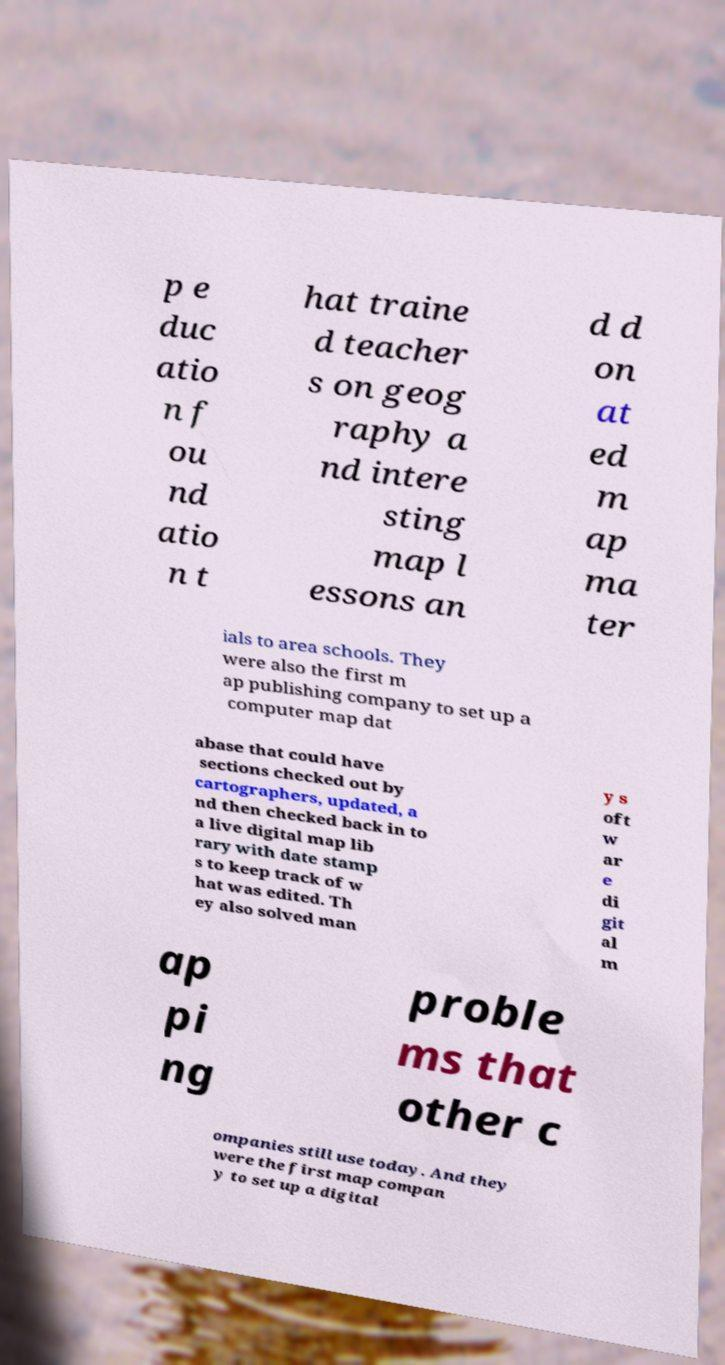Could you extract and type out the text from this image? p e duc atio n f ou nd atio n t hat traine d teacher s on geog raphy a nd intere sting map l essons an d d on at ed m ap ma ter ials to area schools. They were also the first m ap publishing company to set up a computer map dat abase that could have sections checked out by cartographers, updated, a nd then checked back in to a live digital map lib rary with date stamp s to keep track of w hat was edited. Th ey also solved man y s oft w ar e di git al m ap pi ng proble ms that other c ompanies still use today. And they were the first map compan y to set up a digital 